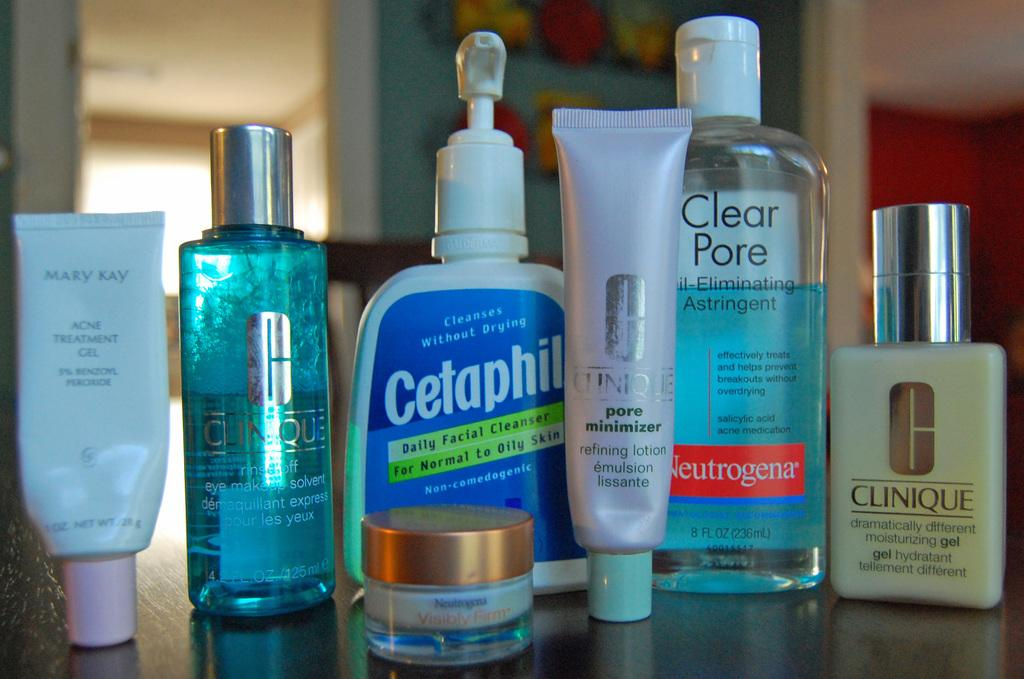<image>
Share a concise interpretation of the image provided. jars and bottles of skin cream like Cetaphil and Clear Pore Astringent 